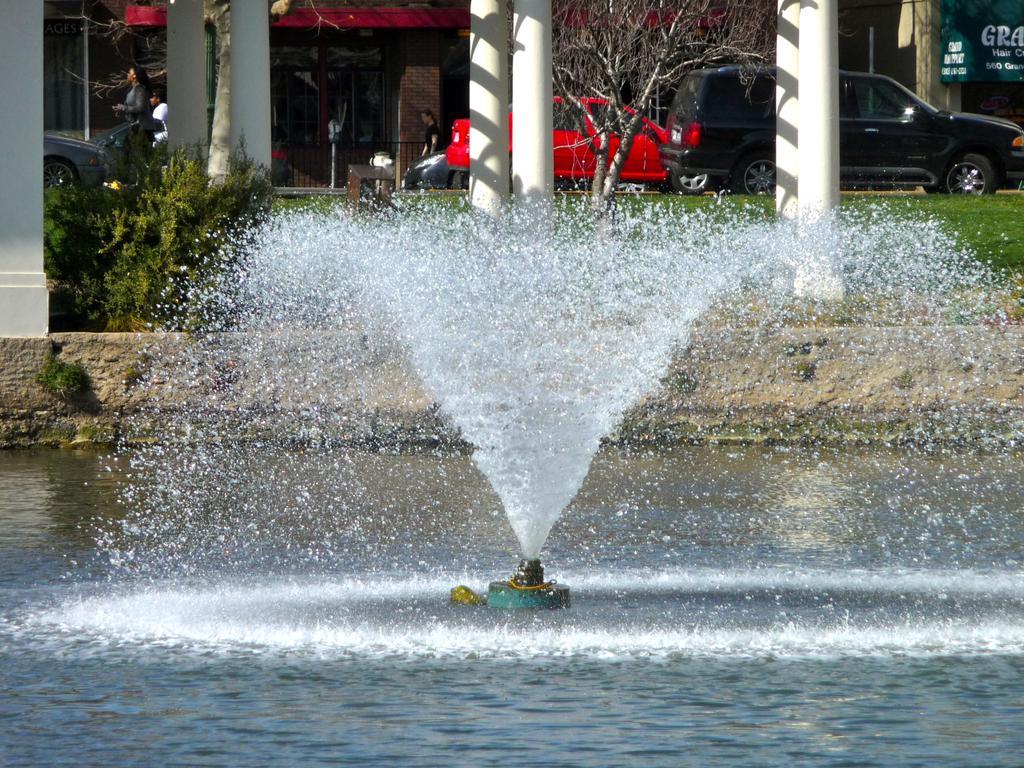Can you describe this image briefly? In this image, we can see a water fountain. Background there are few pillars, plants, grass, trees, vehicles, houses, banner. Here we can see few people. 